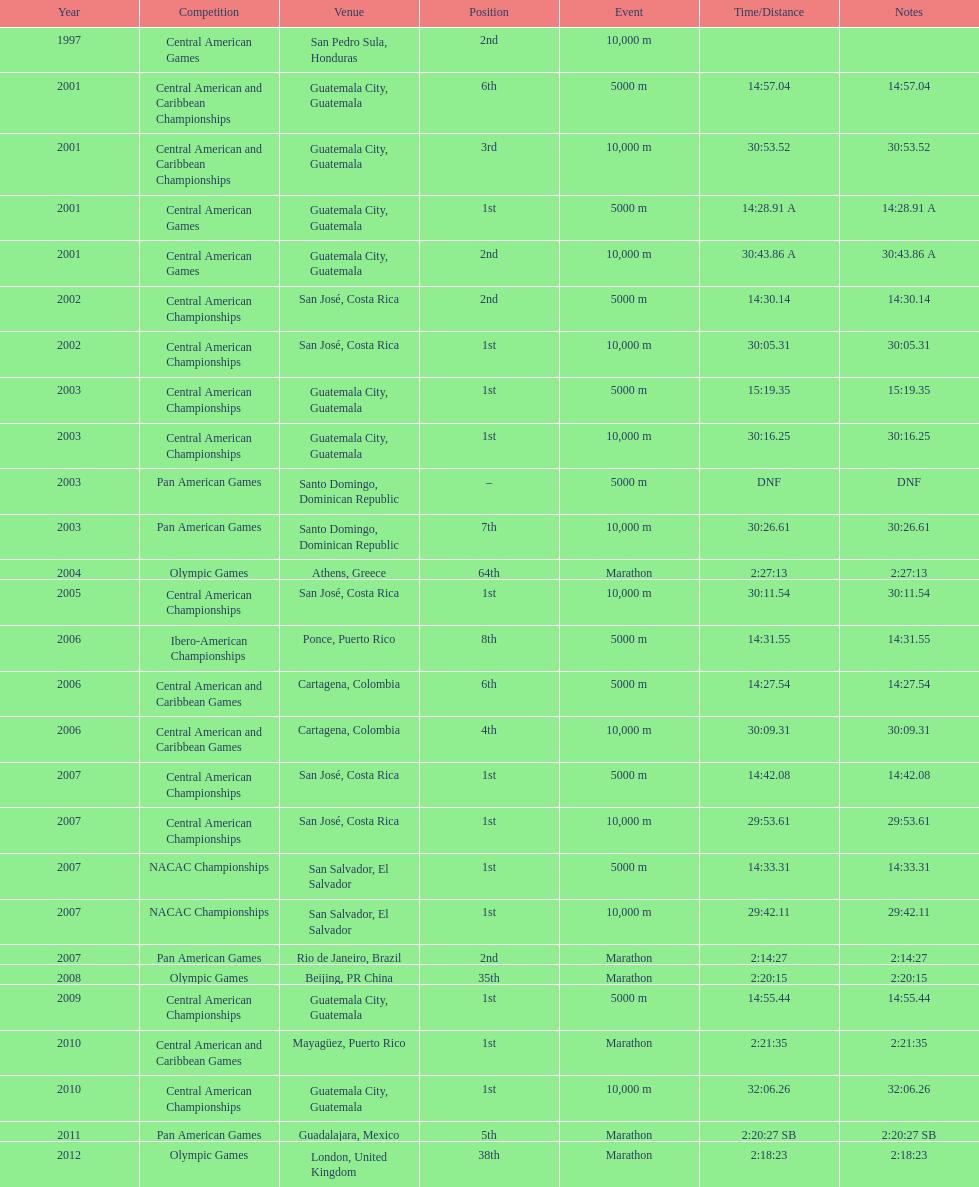Which of each game in 2007 was in the 2nd position? Pan American Games. 